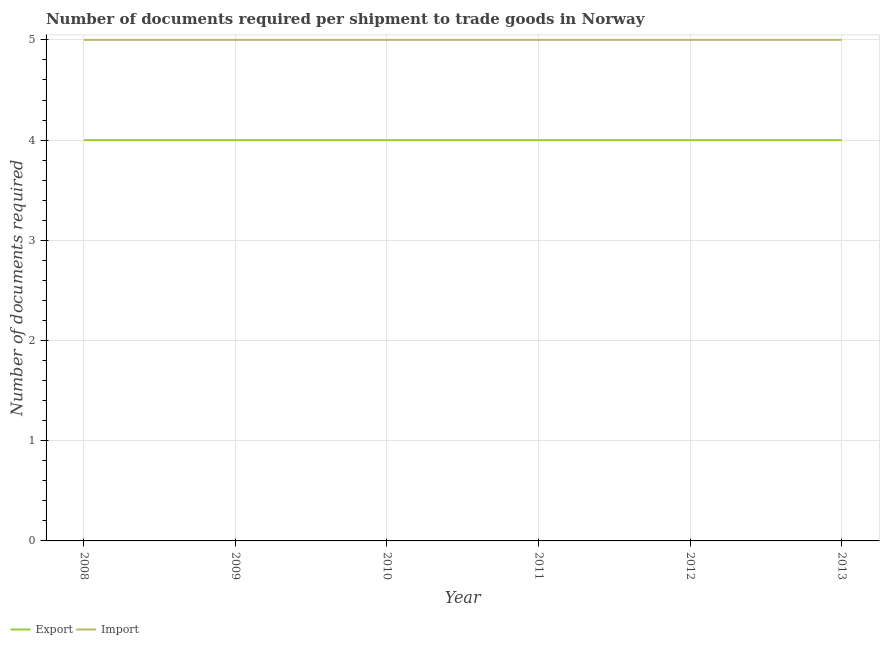How many different coloured lines are there?
Your answer should be compact. 2. What is the number of documents required to import goods in 2012?
Your response must be concise. 5. Across all years, what is the maximum number of documents required to export goods?
Offer a very short reply. 4. Across all years, what is the minimum number of documents required to import goods?
Provide a succinct answer. 5. In which year was the number of documents required to import goods maximum?
Provide a short and direct response. 2008. What is the total number of documents required to export goods in the graph?
Provide a short and direct response. 24. What is the difference between the number of documents required to export goods in 2013 and the number of documents required to import goods in 2010?
Your answer should be compact. -1. In the year 2009, what is the difference between the number of documents required to import goods and number of documents required to export goods?
Give a very brief answer. 1. In how many years, is the number of documents required to import goods greater than 0.4?
Your answer should be compact. 6. What is the ratio of the number of documents required to import goods in 2009 to that in 2012?
Provide a succinct answer. 1. What is the difference between the highest and the second highest number of documents required to import goods?
Give a very brief answer. 0. What is the difference between the highest and the lowest number of documents required to export goods?
Your answer should be compact. 0. In how many years, is the number of documents required to export goods greater than the average number of documents required to export goods taken over all years?
Provide a succinct answer. 0. Is the number of documents required to export goods strictly greater than the number of documents required to import goods over the years?
Give a very brief answer. No. Are the values on the major ticks of Y-axis written in scientific E-notation?
Your answer should be compact. No. Does the graph contain any zero values?
Keep it short and to the point. No. Where does the legend appear in the graph?
Make the answer very short. Bottom left. What is the title of the graph?
Offer a terse response. Number of documents required per shipment to trade goods in Norway. What is the label or title of the Y-axis?
Your answer should be compact. Number of documents required. What is the Number of documents required of Import in 2010?
Provide a short and direct response. 5. What is the Number of documents required of Export in 2011?
Make the answer very short. 4. What is the Number of documents required in Import in 2012?
Provide a short and direct response. 5. What is the Number of documents required in Export in 2013?
Provide a succinct answer. 4. Across all years, what is the maximum Number of documents required in Export?
Your response must be concise. 4. Across all years, what is the maximum Number of documents required in Import?
Provide a succinct answer. 5. What is the total Number of documents required in Import in the graph?
Ensure brevity in your answer.  30. What is the difference between the Number of documents required in Export in 2008 and that in 2009?
Make the answer very short. 0. What is the difference between the Number of documents required of Import in 2008 and that in 2010?
Give a very brief answer. 0. What is the difference between the Number of documents required in Export in 2008 and that in 2011?
Provide a short and direct response. 0. What is the difference between the Number of documents required of Import in 2008 and that in 2011?
Give a very brief answer. 0. What is the difference between the Number of documents required in Export in 2008 and that in 2012?
Your answer should be compact. 0. What is the difference between the Number of documents required of Import in 2008 and that in 2012?
Your answer should be very brief. 0. What is the difference between the Number of documents required of Export in 2008 and that in 2013?
Give a very brief answer. 0. What is the difference between the Number of documents required of Import in 2009 and that in 2010?
Make the answer very short. 0. What is the difference between the Number of documents required in Export in 2009 and that in 2011?
Keep it short and to the point. 0. What is the difference between the Number of documents required in Import in 2009 and that in 2011?
Your answer should be compact. 0. What is the difference between the Number of documents required in Import in 2009 and that in 2013?
Ensure brevity in your answer.  0. What is the difference between the Number of documents required of Import in 2010 and that in 2011?
Make the answer very short. 0. What is the difference between the Number of documents required in Import in 2010 and that in 2012?
Ensure brevity in your answer.  0. What is the difference between the Number of documents required of Export in 2011 and that in 2013?
Ensure brevity in your answer.  0. What is the difference between the Number of documents required in Export in 2012 and that in 2013?
Give a very brief answer. 0. What is the difference between the Number of documents required in Export in 2008 and the Number of documents required in Import in 2009?
Ensure brevity in your answer.  -1. What is the difference between the Number of documents required in Export in 2008 and the Number of documents required in Import in 2010?
Make the answer very short. -1. What is the difference between the Number of documents required of Export in 2008 and the Number of documents required of Import in 2011?
Your answer should be very brief. -1. What is the difference between the Number of documents required of Export in 2008 and the Number of documents required of Import in 2012?
Your answer should be compact. -1. What is the difference between the Number of documents required in Export in 2009 and the Number of documents required in Import in 2010?
Give a very brief answer. -1. What is the difference between the Number of documents required of Export in 2009 and the Number of documents required of Import in 2012?
Provide a succinct answer. -1. What is the difference between the Number of documents required in Export in 2012 and the Number of documents required in Import in 2013?
Give a very brief answer. -1. What is the average Number of documents required in Import per year?
Keep it short and to the point. 5. In the year 2008, what is the difference between the Number of documents required of Export and Number of documents required of Import?
Offer a very short reply. -1. In the year 2010, what is the difference between the Number of documents required of Export and Number of documents required of Import?
Provide a short and direct response. -1. In the year 2012, what is the difference between the Number of documents required of Export and Number of documents required of Import?
Your answer should be compact. -1. What is the ratio of the Number of documents required in Export in 2008 to that in 2009?
Your answer should be compact. 1. What is the ratio of the Number of documents required in Export in 2008 to that in 2010?
Offer a very short reply. 1. What is the ratio of the Number of documents required in Export in 2008 to that in 2011?
Ensure brevity in your answer.  1. What is the ratio of the Number of documents required in Import in 2008 to that in 2012?
Offer a very short reply. 1. What is the ratio of the Number of documents required in Export in 2008 to that in 2013?
Ensure brevity in your answer.  1. What is the ratio of the Number of documents required of Export in 2009 to that in 2010?
Give a very brief answer. 1. What is the ratio of the Number of documents required of Export in 2009 to that in 2011?
Ensure brevity in your answer.  1. What is the ratio of the Number of documents required of Import in 2009 to that in 2011?
Give a very brief answer. 1. What is the ratio of the Number of documents required of Import in 2009 to that in 2012?
Keep it short and to the point. 1. What is the ratio of the Number of documents required in Export in 2009 to that in 2013?
Offer a very short reply. 1. What is the ratio of the Number of documents required of Import in 2009 to that in 2013?
Provide a short and direct response. 1. What is the ratio of the Number of documents required of Export in 2010 to that in 2011?
Your response must be concise. 1. What is the ratio of the Number of documents required of Import in 2010 to that in 2011?
Ensure brevity in your answer.  1. What is the ratio of the Number of documents required in Export in 2011 to that in 2012?
Provide a short and direct response. 1. What is the ratio of the Number of documents required in Import in 2011 to that in 2012?
Offer a terse response. 1. What is the ratio of the Number of documents required of Export in 2011 to that in 2013?
Your answer should be very brief. 1. What is the ratio of the Number of documents required of Import in 2011 to that in 2013?
Give a very brief answer. 1. What is the ratio of the Number of documents required in Import in 2012 to that in 2013?
Your response must be concise. 1. What is the difference between the highest and the lowest Number of documents required in Export?
Ensure brevity in your answer.  0. What is the difference between the highest and the lowest Number of documents required of Import?
Give a very brief answer. 0. 